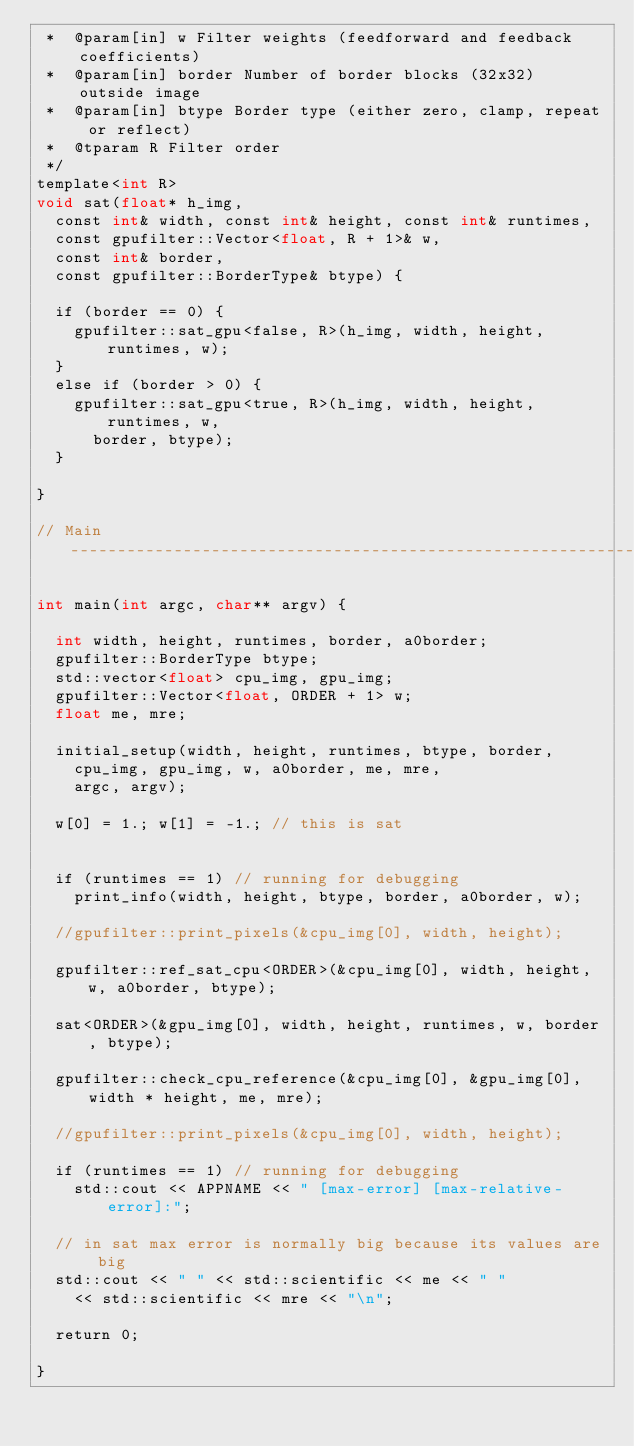Convert code to text. <code><loc_0><loc_0><loc_500><loc_500><_Cuda_> *  @param[in] w Filter weights (feedforward and feedback coefficients)
 *  @param[in] border Number of border blocks (32x32) outside image
 *  @param[in] btype Border type (either zero, clamp, repeat or reflect)
 *  @tparam R Filter order
 */
template<int R>
void sat(float* h_img,
	const int& width, const int& height, const int& runtimes,
	const gpufilter::Vector<float, R + 1>& w,
	const int& border,
	const gpufilter::BorderType& btype) {

	if (border == 0) {
		gpufilter::sat_gpu<false, R>(h_img, width, height, runtimes, w);
	}
	else if (border > 0) {
		gpufilter::sat_gpu<true, R>(h_img, width, height, runtimes, w,
			border, btype);
	}

}

// Main ------------------------------------------------------------------------

int main(int argc, char** argv) {

	int width, height, runtimes, border, a0border;
	gpufilter::BorderType btype;
	std::vector<float> cpu_img, gpu_img;
	gpufilter::Vector<float, ORDER + 1> w;
	float me, mre;

	initial_setup(width, height, runtimes, btype, border,
		cpu_img, gpu_img, w, a0border, me, mre,
		argc, argv);

	w[0] = 1.; w[1] = -1.; // this is sat


	if (runtimes == 1) // running for debugging
		print_info(width, height, btype, border, a0border, w);

	//gpufilter::print_pixels(&cpu_img[0], width, height);

	gpufilter::ref_sat_cpu<ORDER>(&cpu_img[0], width, height, w, a0border, btype);

	sat<ORDER>(&gpu_img[0], width, height, runtimes, w, border, btype);

	gpufilter::check_cpu_reference(&cpu_img[0], &gpu_img[0], width * height, me, mre);

	//gpufilter::print_pixels(&cpu_img[0], width, height);

	if (runtimes == 1) // running for debugging
		std::cout << APPNAME << " [max-error] [max-relative-error]:";

	// in sat max error is normally big because its values are big
	std::cout << " " << std::scientific << me << " "
		<< std::scientific << mre << "\n";

	return 0;

}
</code> 